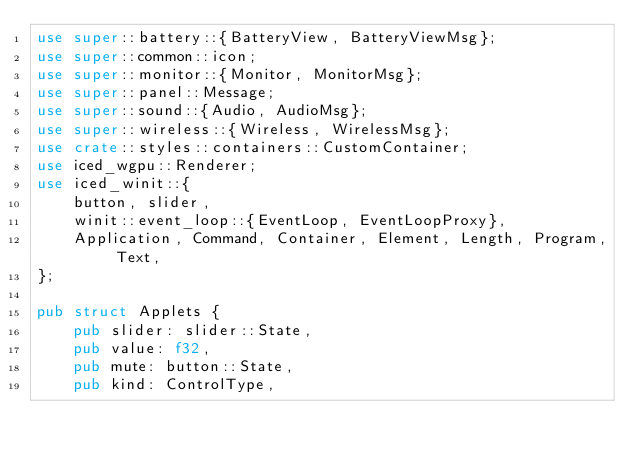Convert code to text. <code><loc_0><loc_0><loc_500><loc_500><_Rust_>use super::battery::{BatteryView, BatteryViewMsg};
use super::common::icon;
use super::monitor::{Monitor, MonitorMsg};
use super::panel::Message;
use super::sound::{Audio, AudioMsg};
use super::wireless::{Wireless, WirelessMsg};
use crate::styles::containers::CustomContainer;
use iced_wgpu::Renderer;
use iced_winit::{
    button, slider,
    winit::event_loop::{EventLoop, EventLoopProxy},
    Application, Command, Container, Element, Length, Program, Text,
};

pub struct Applets {
    pub slider: slider::State,
    pub value: f32,
    pub mute: button::State,
    pub kind: ControlType,</code> 